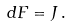<formula> <loc_0><loc_0><loc_500><loc_500>d F = J \, .</formula> 